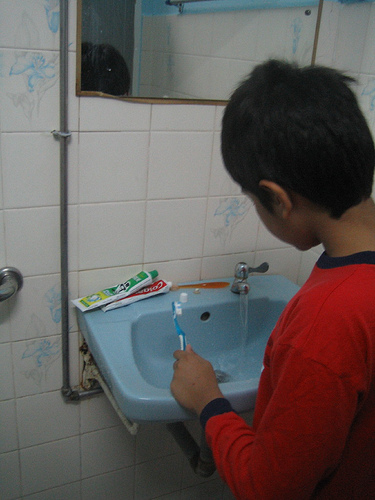Please transcribe the text in this image. Colgate 